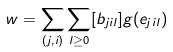Convert formula to latex. <formula><loc_0><loc_0><loc_500><loc_500>w = \sum _ { ( j , i ) } \sum _ { l \geq 0 } [ b _ { j i l } ] g ( e _ { j i l } )</formula> 